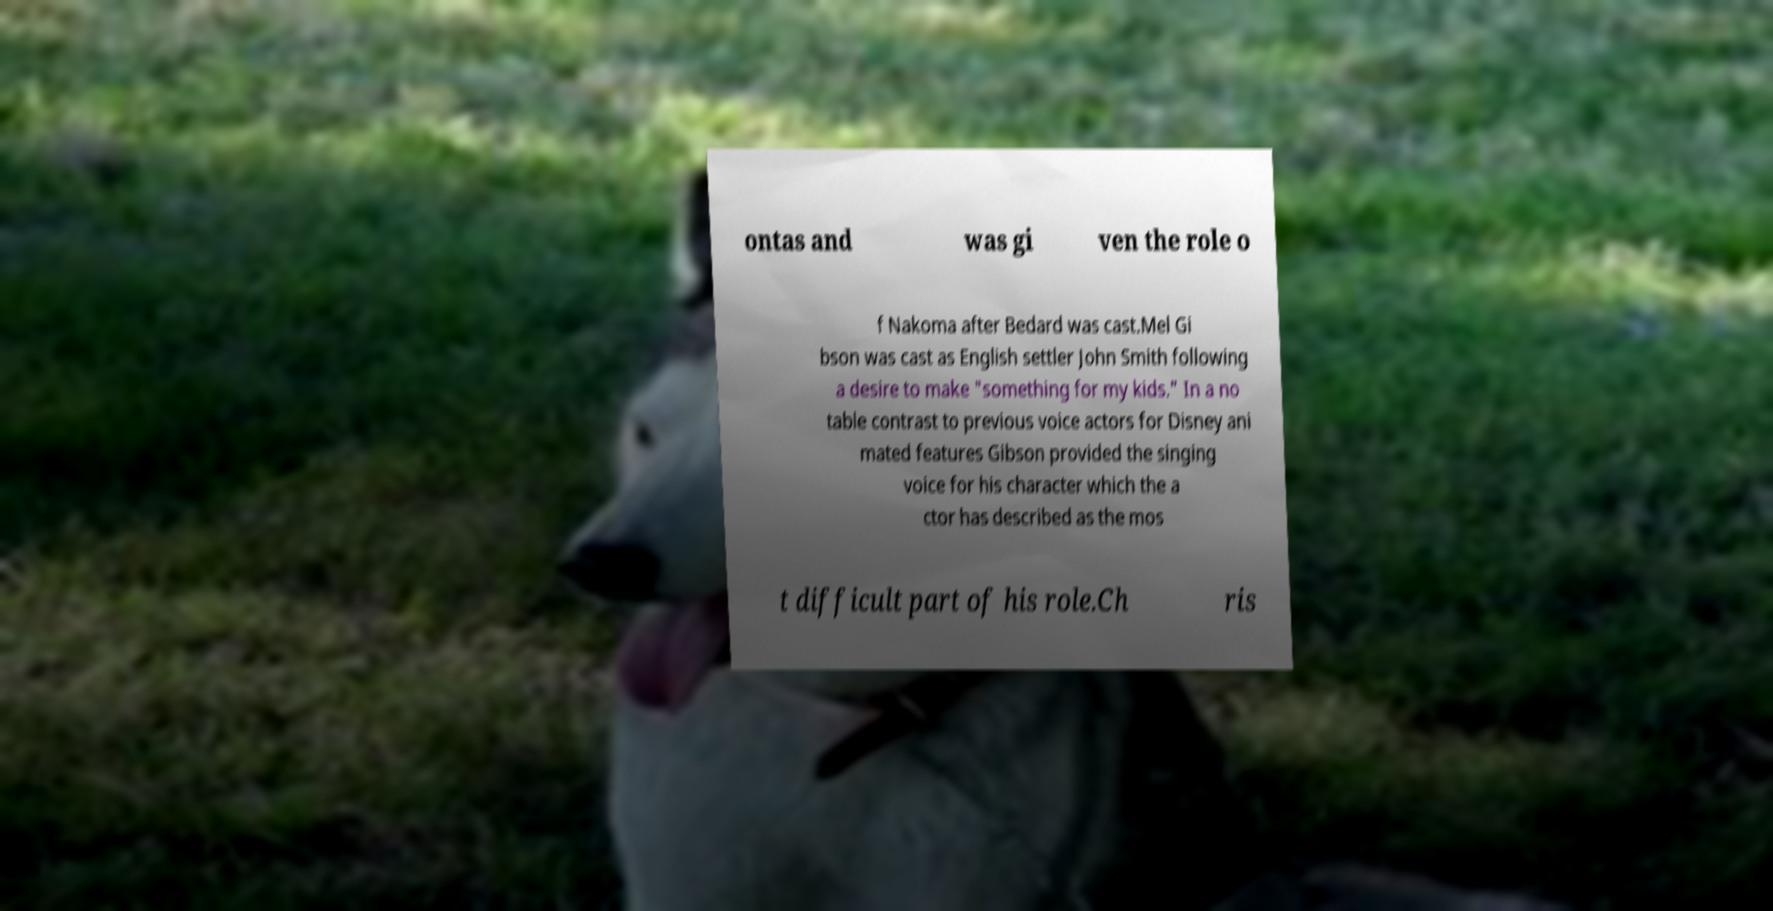Can you accurately transcribe the text from the provided image for me? ontas and was gi ven the role o f Nakoma after Bedard was cast.Mel Gi bson was cast as English settler John Smith following a desire to make "something for my kids." In a no table contrast to previous voice actors for Disney ani mated features Gibson provided the singing voice for his character which the a ctor has described as the mos t difficult part of his role.Ch ris 